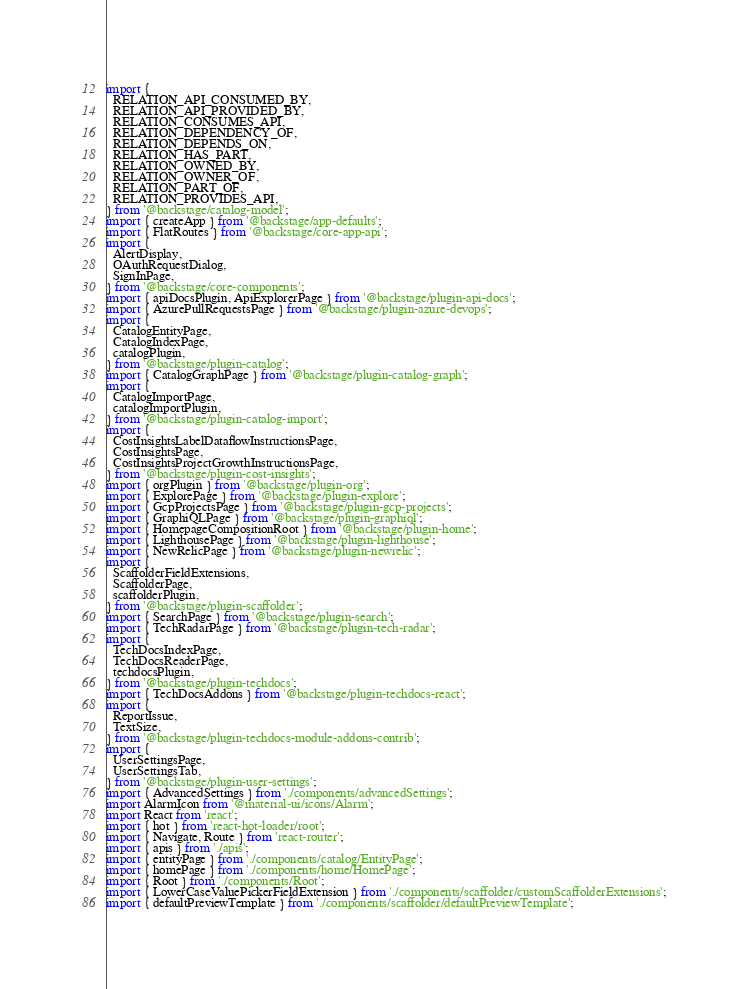Convert code to text. <code><loc_0><loc_0><loc_500><loc_500><_TypeScript_>import {
  RELATION_API_CONSUMED_BY,
  RELATION_API_PROVIDED_BY,
  RELATION_CONSUMES_API,
  RELATION_DEPENDENCY_OF,
  RELATION_DEPENDS_ON,
  RELATION_HAS_PART,
  RELATION_OWNED_BY,
  RELATION_OWNER_OF,
  RELATION_PART_OF,
  RELATION_PROVIDES_API,
} from '@backstage/catalog-model';
import { createApp } from '@backstage/app-defaults';
import { FlatRoutes } from '@backstage/core-app-api';
import {
  AlertDisplay,
  OAuthRequestDialog,
  SignInPage,
} from '@backstage/core-components';
import { apiDocsPlugin, ApiExplorerPage } from '@backstage/plugin-api-docs';
import { AzurePullRequestsPage } from '@backstage/plugin-azure-devops';
import {
  CatalogEntityPage,
  CatalogIndexPage,
  catalogPlugin,
} from '@backstage/plugin-catalog';
import { CatalogGraphPage } from '@backstage/plugin-catalog-graph';
import {
  CatalogImportPage,
  catalogImportPlugin,
} from '@backstage/plugin-catalog-import';
import {
  CostInsightsLabelDataflowInstructionsPage,
  CostInsightsPage,
  CostInsightsProjectGrowthInstructionsPage,
} from '@backstage/plugin-cost-insights';
import { orgPlugin } from '@backstage/plugin-org';
import { ExplorePage } from '@backstage/plugin-explore';
import { GcpProjectsPage } from '@backstage/plugin-gcp-projects';
import { GraphiQLPage } from '@backstage/plugin-graphiql';
import { HomepageCompositionRoot } from '@backstage/plugin-home';
import { LighthousePage } from '@backstage/plugin-lighthouse';
import { NewRelicPage } from '@backstage/plugin-newrelic';
import {
  ScaffolderFieldExtensions,
  ScaffolderPage,
  scaffolderPlugin,
} from '@backstage/plugin-scaffolder';
import { SearchPage } from '@backstage/plugin-search';
import { TechRadarPage } from '@backstage/plugin-tech-radar';
import {
  TechDocsIndexPage,
  TechDocsReaderPage,
  techdocsPlugin,
} from '@backstage/plugin-techdocs';
import { TechDocsAddons } from '@backstage/plugin-techdocs-react';
import {
  ReportIssue,
  TextSize,
} from '@backstage/plugin-techdocs-module-addons-contrib';
import {
  UserSettingsPage,
  UserSettingsTab,
} from '@backstage/plugin-user-settings';
import { AdvancedSettings } from './components/advancedSettings';
import AlarmIcon from '@material-ui/icons/Alarm';
import React from 'react';
import { hot } from 'react-hot-loader/root';
import { Navigate, Route } from 'react-router';
import { apis } from './apis';
import { entityPage } from './components/catalog/EntityPage';
import { homePage } from './components/home/HomePage';
import { Root } from './components/Root';
import { LowerCaseValuePickerFieldExtension } from './components/scaffolder/customScaffolderExtensions';
import { defaultPreviewTemplate } from './components/scaffolder/defaultPreviewTemplate';</code> 